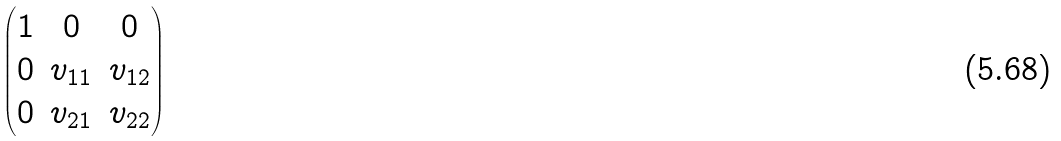Convert formula to latex. <formula><loc_0><loc_0><loc_500><loc_500>\begin{pmatrix} 1 & 0 & 0 \\ 0 & v _ { 1 1 } & v _ { 1 2 } \\ 0 & v _ { 2 1 } & v _ { 2 2 } \end{pmatrix}</formula> 